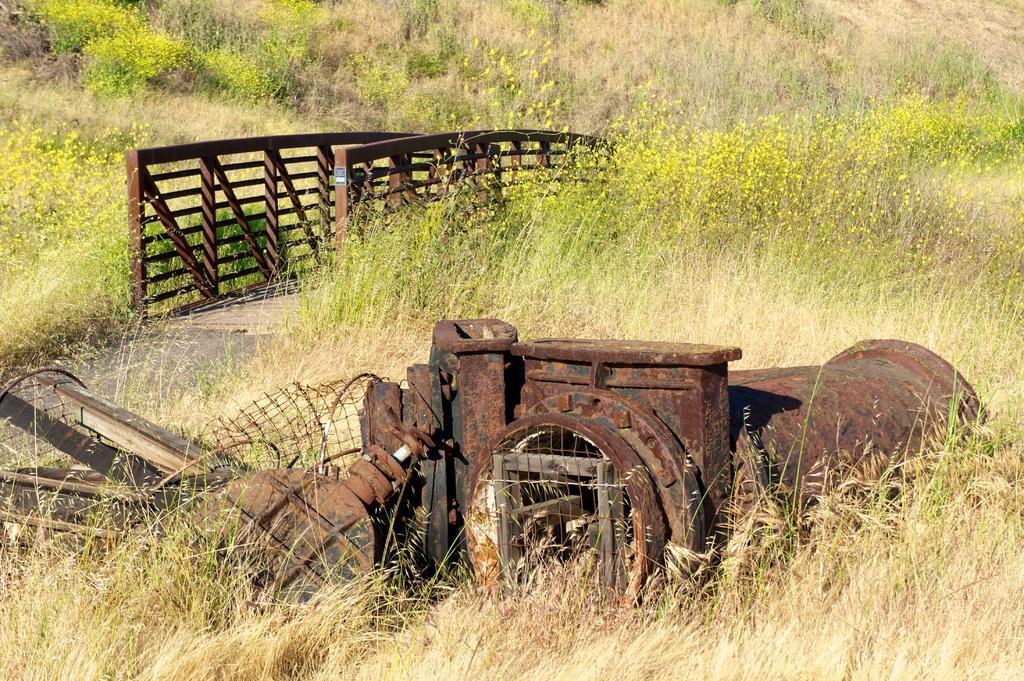In one or two sentences, can you explain what this image depicts? This is an outside view. In this image, I can see the grass and plants on the ground. At the bottom there is a metal object placed on the ground. On the left side there is a path, on both sides of it I can see the railings. 